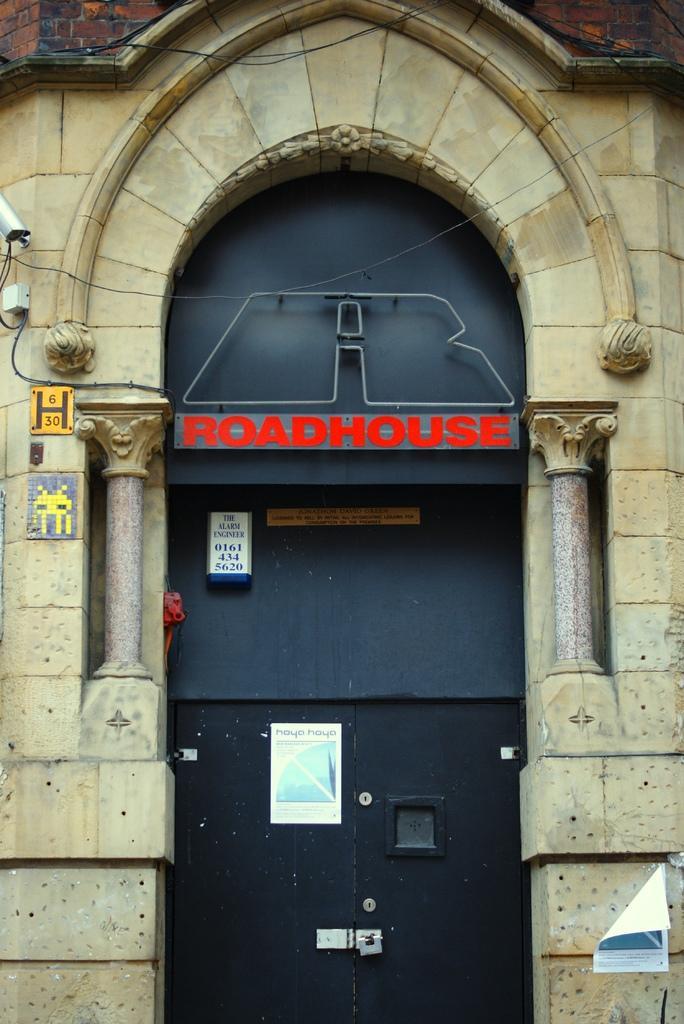In one or two sentences, can you explain what this image depicts? In this image there is a building in the middle. At the bottom there is a door. At the top there is a hoarding. On the right side bottom there is a poster attached to the wall. On the left side there are two small boards to the wall. Behind them there is a video camera which is attached to the wall. 